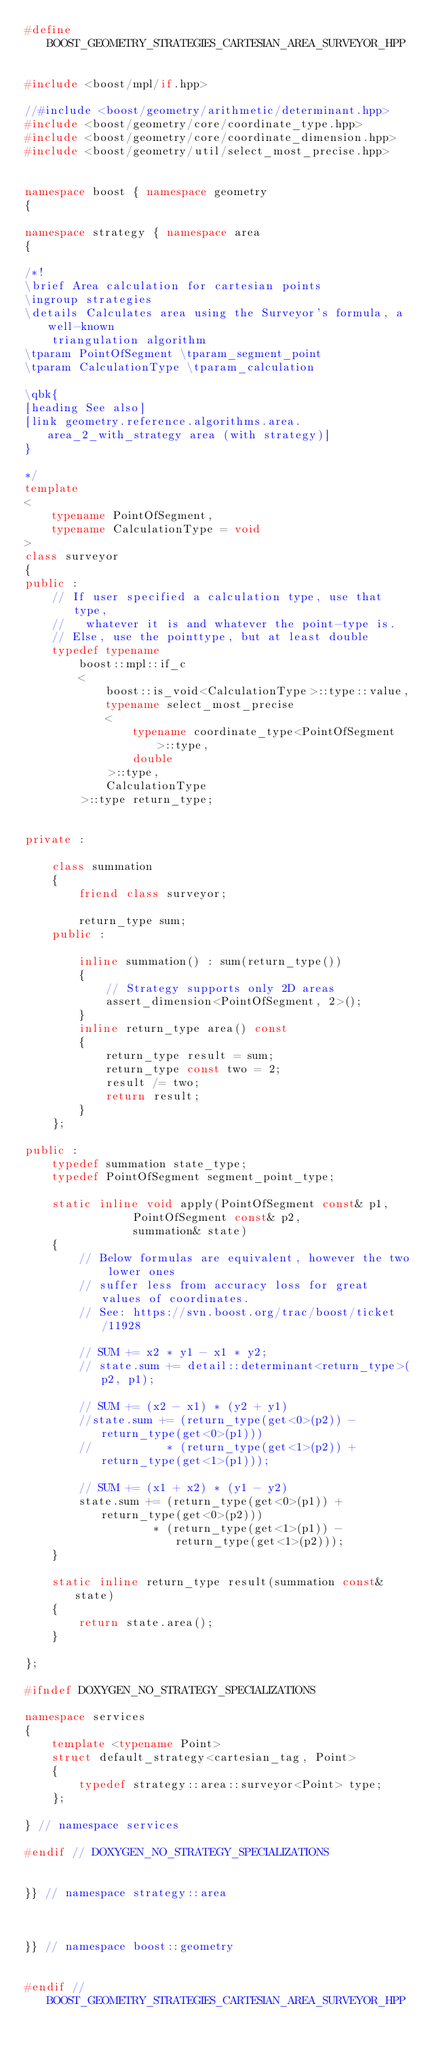<code> <loc_0><loc_0><loc_500><loc_500><_C++_>#define BOOST_GEOMETRY_STRATEGIES_CARTESIAN_AREA_SURVEYOR_HPP


#include <boost/mpl/if.hpp>

//#include <boost/geometry/arithmetic/determinant.hpp>
#include <boost/geometry/core/coordinate_type.hpp>
#include <boost/geometry/core/coordinate_dimension.hpp>
#include <boost/geometry/util/select_most_precise.hpp>


namespace boost { namespace geometry
{

namespace strategy { namespace area
{

/*!
\brief Area calculation for cartesian points
\ingroup strategies
\details Calculates area using the Surveyor's formula, a well-known
    triangulation algorithm
\tparam PointOfSegment \tparam_segment_point
\tparam CalculationType \tparam_calculation

\qbk{
[heading See also]
[link geometry.reference.algorithms.area.area_2_with_strategy area (with strategy)]
}

*/
template
<
    typename PointOfSegment,
    typename CalculationType = void
>
class surveyor
{
public :
    // If user specified a calculation type, use that type,
    //   whatever it is and whatever the point-type is.
    // Else, use the pointtype, but at least double
    typedef typename
        boost::mpl::if_c
        <
            boost::is_void<CalculationType>::type::value,
            typename select_most_precise
            <
                typename coordinate_type<PointOfSegment>::type,
                double
            >::type,
            CalculationType
        >::type return_type;


private :

    class summation
    {
        friend class surveyor;

        return_type sum;
    public :

        inline summation() : sum(return_type())
        {
            // Strategy supports only 2D areas
            assert_dimension<PointOfSegment, 2>();
        }
        inline return_type area() const
        {
            return_type result = sum;
            return_type const two = 2;
            result /= two;
            return result;
        }
    };

public :
    typedef summation state_type;
    typedef PointOfSegment segment_point_type;

    static inline void apply(PointOfSegment const& p1,
                PointOfSegment const& p2,
                summation& state)
    {
        // Below formulas are equivalent, however the two lower ones
        // suffer less from accuracy loss for great values of coordinates.
        // See: https://svn.boost.org/trac/boost/ticket/11928

        // SUM += x2 * y1 - x1 * y2;
        // state.sum += detail::determinant<return_type>(p2, p1);

        // SUM += (x2 - x1) * (y2 + y1)
        //state.sum += (return_type(get<0>(p2)) - return_type(get<0>(p1)))
        //           * (return_type(get<1>(p2)) + return_type(get<1>(p1)));

        // SUM += (x1 + x2) * (y1 - y2)
        state.sum += (return_type(get<0>(p1)) + return_type(get<0>(p2)))
                   * (return_type(get<1>(p1)) - return_type(get<1>(p2)));
    }

    static inline return_type result(summation const& state)
    {
        return state.area();
    }

};

#ifndef DOXYGEN_NO_STRATEGY_SPECIALIZATIONS

namespace services
{
    template <typename Point>
    struct default_strategy<cartesian_tag, Point>
    {
        typedef strategy::area::surveyor<Point> type;
    };

} // namespace services

#endif // DOXYGEN_NO_STRATEGY_SPECIALIZATIONS


}} // namespace strategy::area



}} // namespace boost::geometry


#endif // BOOST_GEOMETRY_STRATEGIES_CARTESIAN_AREA_SURVEYOR_HPP
</code> 